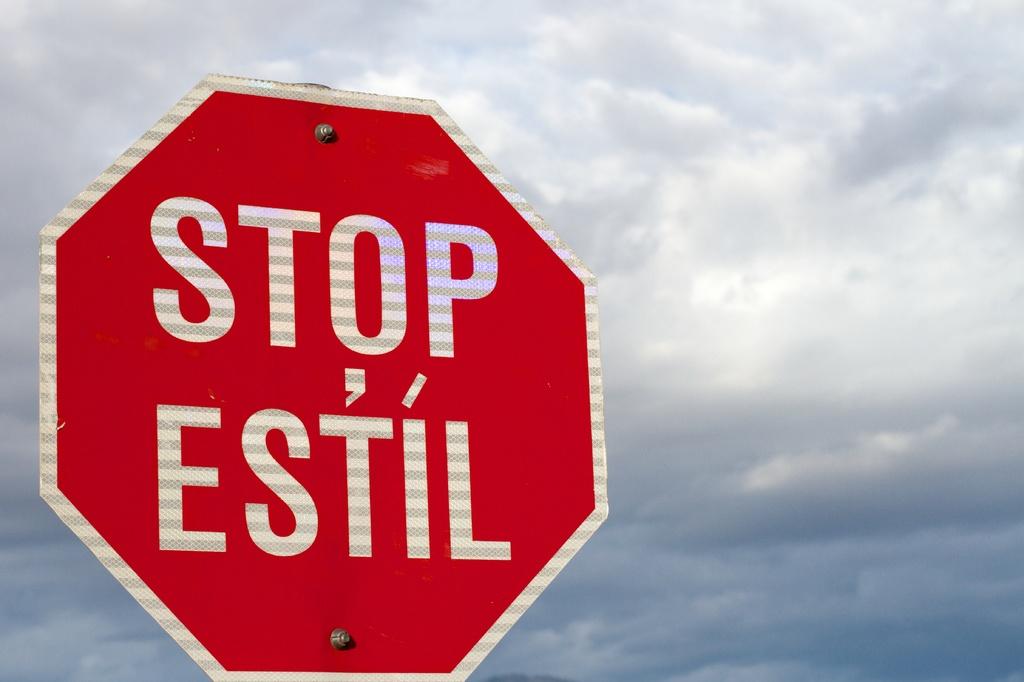What does this road sign mean?
Make the answer very short. Stop. Which letters have accents over them?
Offer a terse response. Ti. 